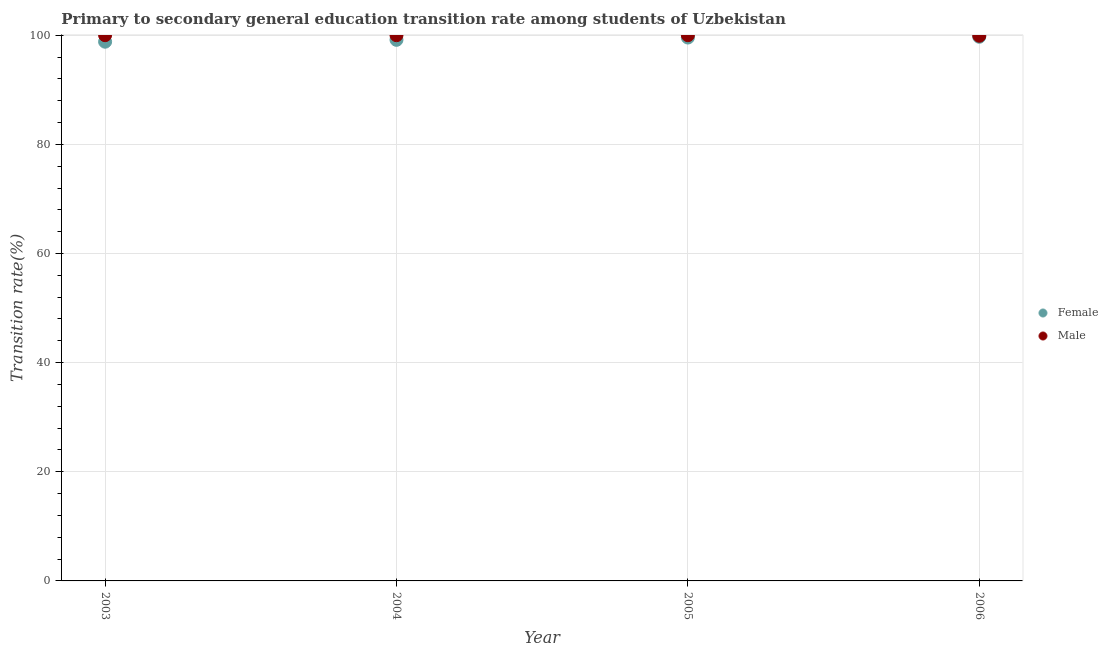Across all years, what is the maximum transition rate among female students?
Ensure brevity in your answer.  99.71. Across all years, what is the minimum transition rate among male students?
Your response must be concise. 99.9. In which year was the transition rate among female students maximum?
Provide a short and direct response. 2006. In which year was the transition rate among male students minimum?
Make the answer very short. 2006. What is the total transition rate among male students in the graph?
Provide a succinct answer. 399.9. What is the difference between the transition rate among male students in 2004 and that in 2006?
Your answer should be compact. 0.1. What is the difference between the transition rate among male students in 2006 and the transition rate among female students in 2005?
Make the answer very short. 0.33. What is the average transition rate among male students per year?
Your answer should be compact. 99.98. In the year 2006, what is the difference between the transition rate among male students and transition rate among female students?
Give a very brief answer. 0.19. What is the ratio of the transition rate among female students in 2003 to that in 2004?
Offer a terse response. 1. Is the transition rate among male students in 2004 less than that in 2005?
Provide a short and direct response. No. Is the difference between the transition rate among female students in 2003 and 2006 greater than the difference between the transition rate among male students in 2003 and 2006?
Provide a short and direct response. No. What is the difference between the highest and the lowest transition rate among female students?
Ensure brevity in your answer.  0.9. In how many years, is the transition rate among male students greater than the average transition rate among male students taken over all years?
Provide a short and direct response. 3. Is the sum of the transition rate among female students in 2003 and 2006 greater than the maximum transition rate among male students across all years?
Offer a terse response. Yes. Does the transition rate among female students monotonically increase over the years?
Your response must be concise. Yes. Is the transition rate among female students strictly greater than the transition rate among male students over the years?
Give a very brief answer. No. Is the transition rate among male students strictly less than the transition rate among female students over the years?
Provide a short and direct response. No. How many dotlines are there?
Offer a terse response. 2. What is the difference between two consecutive major ticks on the Y-axis?
Your response must be concise. 20. Are the values on the major ticks of Y-axis written in scientific E-notation?
Your answer should be compact. No. Does the graph contain any zero values?
Your response must be concise. No. How are the legend labels stacked?
Offer a very short reply. Vertical. What is the title of the graph?
Your answer should be very brief. Primary to secondary general education transition rate among students of Uzbekistan. What is the label or title of the Y-axis?
Keep it short and to the point. Transition rate(%). What is the Transition rate(%) in Female in 2003?
Provide a short and direct response. 98.81. What is the Transition rate(%) in Female in 2004?
Offer a very short reply. 99.15. What is the Transition rate(%) in Female in 2005?
Your answer should be very brief. 99.57. What is the Transition rate(%) in Female in 2006?
Your answer should be very brief. 99.71. What is the Transition rate(%) of Male in 2006?
Your answer should be very brief. 99.9. Across all years, what is the maximum Transition rate(%) of Female?
Make the answer very short. 99.71. Across all years, what is the minimum Transition rate(%) of Female?
Your response must be concise. 98.81. Across all years, what is the minimum Transition rate(%) in Male?
Your response must be concise. 99.9. What is the total Transition rate(%) in Female in the graph?
Ensure brevity in your answer.  397.24. What is the total Transition rate(%) in Male in the graph?
Ensure brevity in your answer.  399.9. What is the difference between the Transition rate(%) of Female in 2003 and that in 2004?
Provide a short and direct response. -0.34. What is the difference between the Transition rate(%) of Female in 2003 and that in 2005?
Provide a succinct answer. -0.76. What is the difference between the Transition rate(%) of Female in 2003 and that in 2006?
Your response must be concise. -0.9. What is the difference between the Transition rate(%) in Male in 2003 and that in 2006?
Offer a very short reply. 0.1. What is the difference between the Transition rate(%) of Female in 2004 and that in 2005?
Your answer should be compact. -0.42. What is the difference between the Transition rate(%) of Male in 2004 and that in 2005?
Ensure brevity in your answer.  0. What is the difference between the Transition rate(%) in Female in 2004 and that in 2006?
Make the answer very short. -0.56. What is the difference between the Transition rate(%) in Male in 2004 and that in 2006?
Offer a very short reply. 0.1. What is the difference between the Transition rate(%) in Female in 2005 and that in 2006?
Make the answer very short. -0.14. What is the difference between the Transition rate(%) of Male in 2005 and that in 2006?
Give a very brief answer. 0.1. What is the difference between the Transition rate(%) of Female in 2003 and the Transition rate(%) of Male in 2004?
Your response must be concise. -1.19. What is the difference between the Transition rate(%) in Female in 2003 and the Transition rate(%) in Male in 2005?
Your answer should be compact. -1.19. What is the difference between the Transition rate(%) in Female in 2003 and the Transition rate(%) in Male in 2006?
Offer a very short reply. -1.09. What is the difference between the Transition rate(%) in Female in 2004 and the Transition rate(%) in Male in 2005?
Your answer should be compact. -0.85. What is the difference between the Transition rate(%) of Female in 2004 and the Transition rate(%) of Male in 2006?
Make the answer very short. -0.75. What is the difference between the Transition rate(%) in Female in 2005 and the Transition rate(%) in Male in 2006?
Offer a very short reply. -0.33. What is the average Transition rate(%) in Female per year?
Offer a very short reply. 99.31. What is the average Transition rate(%) of Male per year?
Your answer should be very brief. 99.97. In the year 2003, what is the difference between the Transition rate(%) in Female and Transition rate(%) in Male?
Your response must be concise. -1.19. In the year 2004, what is the difference between the Transition rate(%) of Female and Transition rate(%) of Male?
Provide a short and direct response. -0.85. In the year 2005, what is the difference between the Transition rate(%) in Female and Transition rate(%) in Male?
Offer a terse response. -0.43. In the year 2006, what is the difference between the Transition rate(%) of Female and Transition rate(%) of Male?
Keep it short and to the point. -0.19. What is the ratio of the Transition rate(%) of Male in 2003 to that in 2005?
Ensure brevity in your answer.  1. What is the ratio of the Transition rate(%) of Female in 2003 to that in 2006?
Give a very brief answer. 0.99. What is the ratio of the Transition rate(%) of Male in 2003 to that in 2006?
Keep it short and to the point. 1. What is the difference between the highest and the second highest Transition rate(%) in Female?
Make the answer very short. 0.14. What is the difference between the highest and the lowest Transition rate(%) in Female?
Offer a very short reply. 0.9. What is the difference between the highest and the lowest Transition rate(%) in Male?
Ensure brevity in your answer.  0.1. 